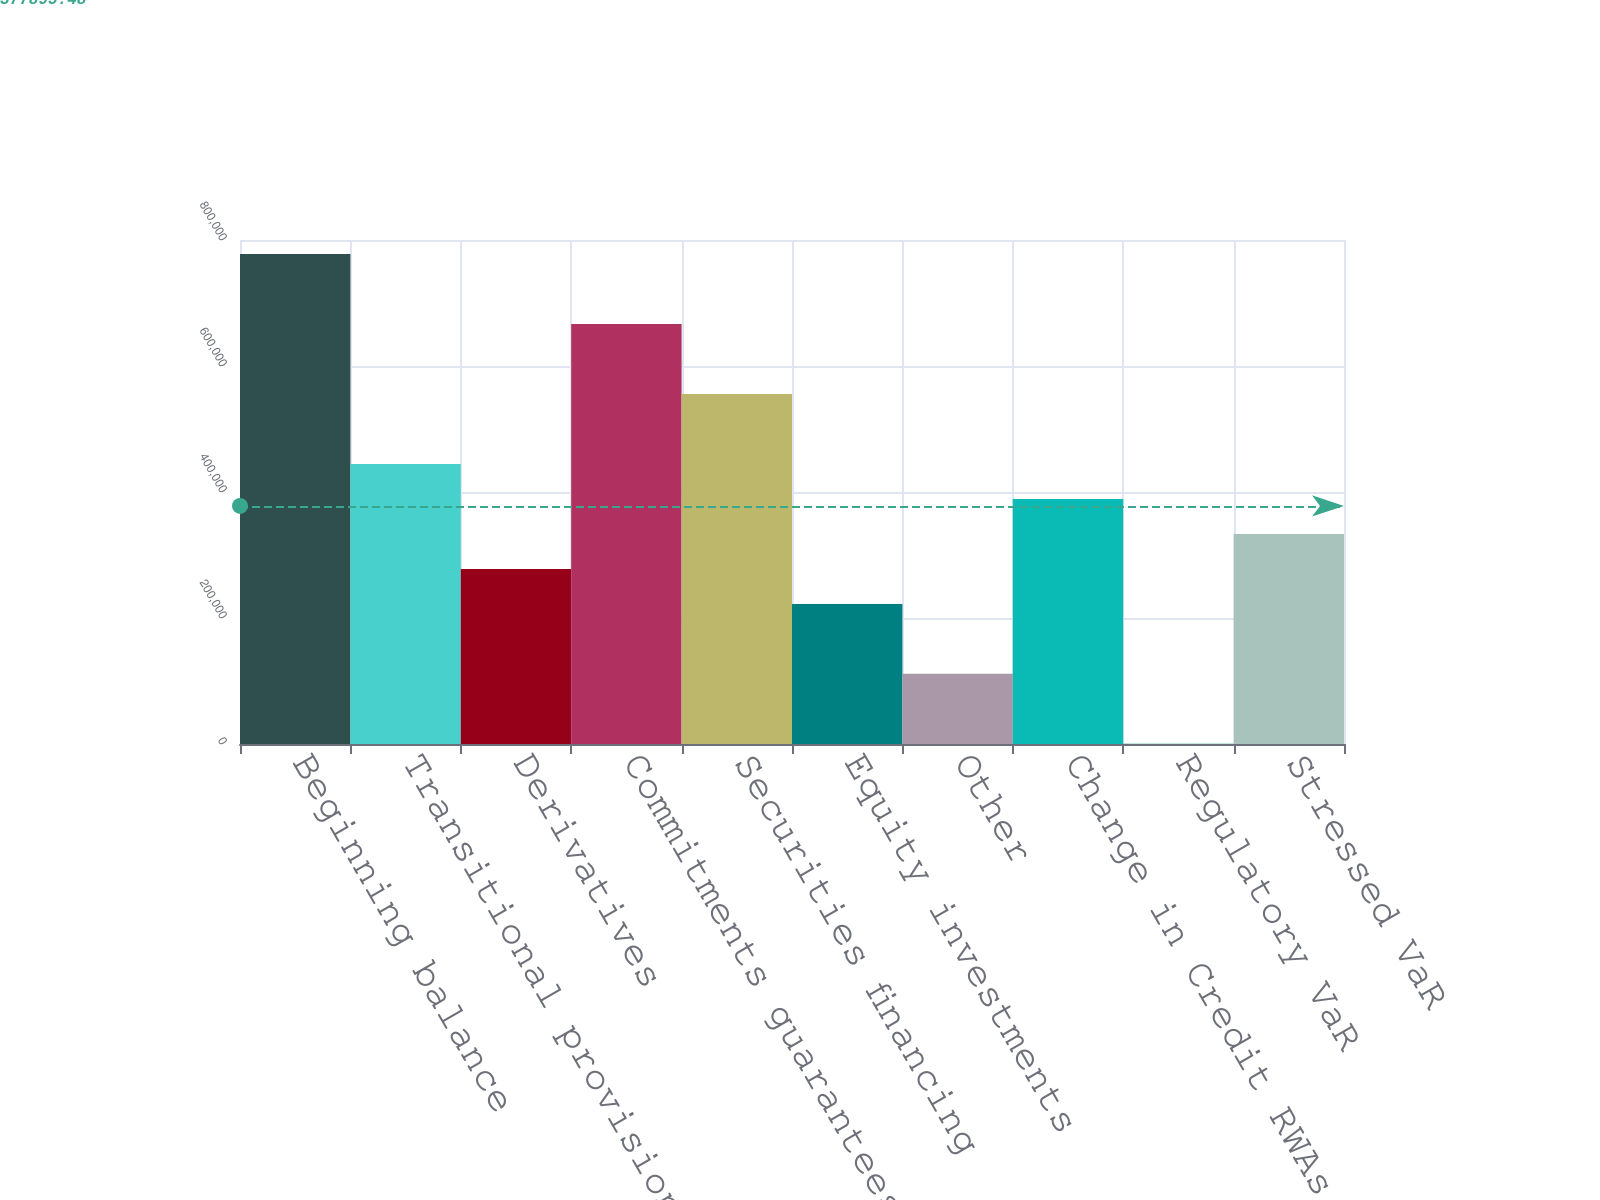Convert chart. <chart><loc_0><loc_0><loc_500><loc_500><bar_chart><fcel>Beginning balance<fcel>Transitional provisions<fcel>Derivatives<fcel>Commitments guarantees and<fcel>Securities financing<fcel>Equity investments<fcel>Other<fcel>Change in Credit RWAs<fcel>Regulatory VaR<fcel>Stressed VaR<nl><fcel>777755<fcel>444539<fcel>277930<fcel>666683<fcel>555611<fcel>222394<fcel>111322<fcel>389003<fcel>250<fcel>333467<nl></chart> 